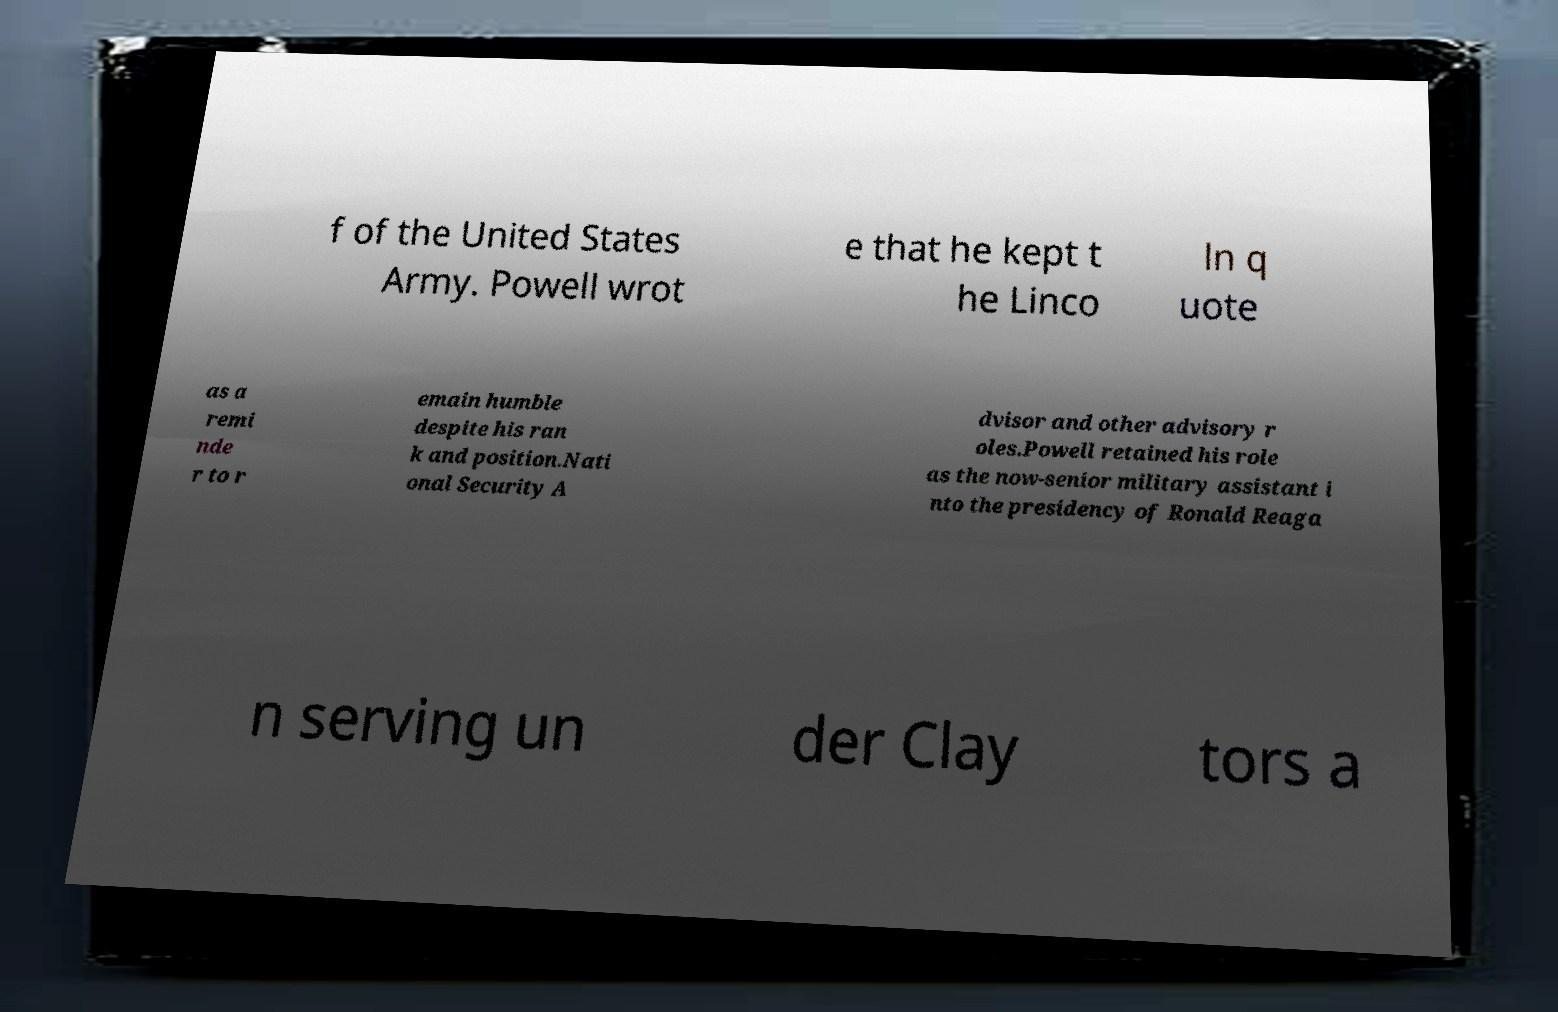I need the written content from this picture converted into text. Can you do that? f of the United States Army. Powell wrot e that he kept t he Linco ln q uote as a remi nde r to r emain humble despite his ran k and position.Nati onal Security A dvisor and other advisory r oles.Powell retained his role as the now-senior military assistant i nto the presidency of Ronald Reaga n serving un der Clay tors a 